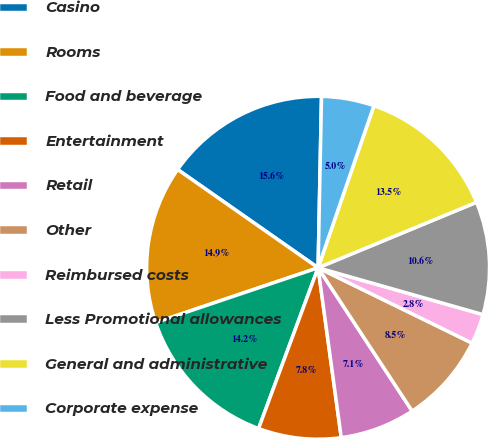Convert chart. <chart><loc_0><loc_0><loc_500><loc_500><pie_chart><fcel>Casino<fcel>Rooms<fcel>Food and beverage<fcel>Entertainment<fcel>Retail<fcel>Other<fcel>Reimbursed costs<fcel>Less Promotional allowances<fcel>General and administrative<fcel>Corporate expense<nl><fcel>15.6%<fcel>14.89%<fcel>14.18%<fcel>7.8%<fcel>7.09%<fcel>8.51%<fcel>2.84%<fcel>10.64%<fcel>13.48%<fcel>4.96%<nl></chart> 